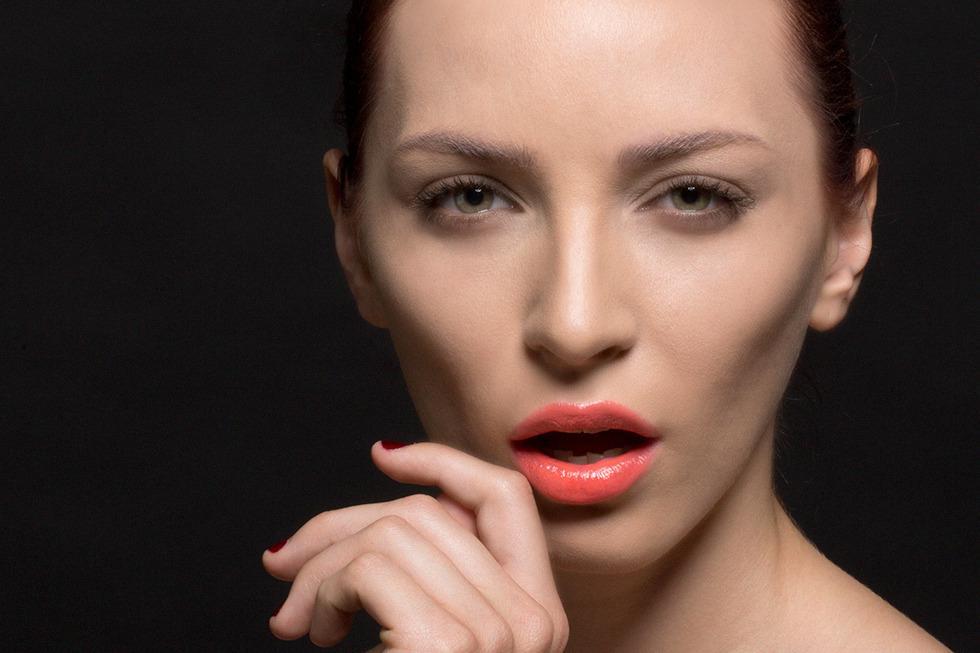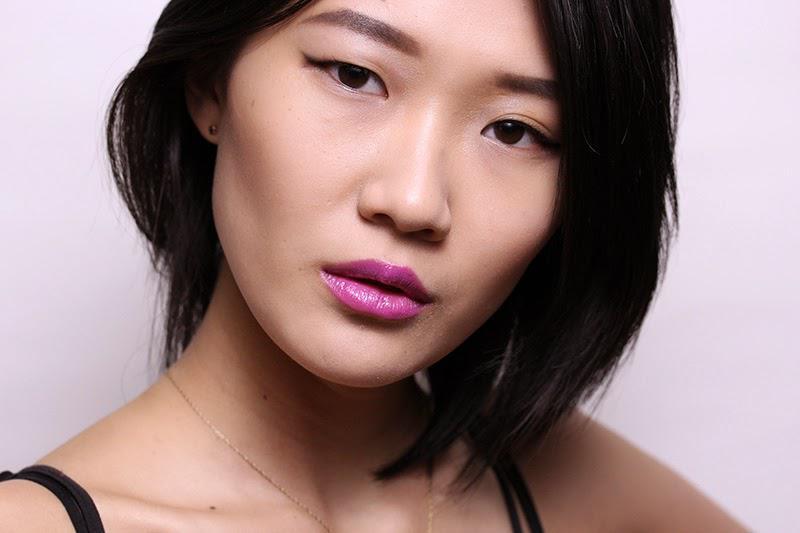The first image is the image on the left, the second image is the image on the right. Analyze the images presented: Is the assertion "An image shows an Asian model with lavender-tinted lips and thin black straps on her shoulders." valid? Answer yes or no. Yes. The first image is the image on the left, the second image is the image on the right. For the images shown, is this caption "The woman in one of the images has her hand near her chin." true? Answer yes or no. Yes. 